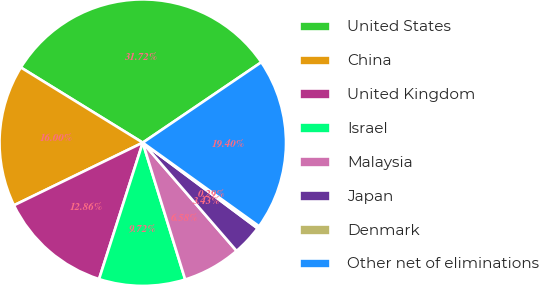Convert chart. <chart><loc_0><loc_0><loc_500><loc_500><pie_chart><fcel>United States<fcel>China<fcel>United Kingdom<fcel>Israel<fcel>Malaysia<fcel>Japan<fcel>Denmark<fcel>Other net of eliminations<nl><fcel>31.72%<fcel>16.0%<fcel>12.86%<fcel>9.72%<fcel>6.58%<fcel>3.43%<fcel>0.29%<fcel>19.4%<nl></chart> 